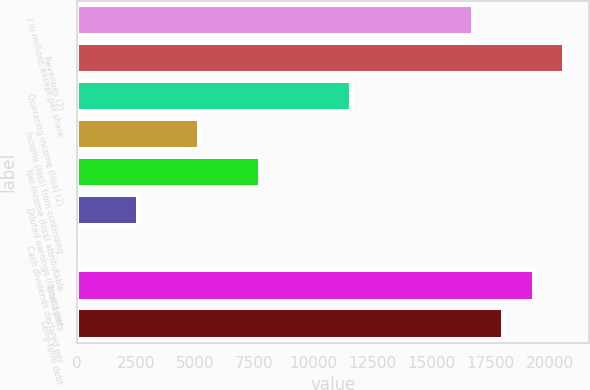Convert chart. <chart><loc_0><loc_0><loc_500><loc_500><bar_chart><fcel>( in millions except per share<fcel>Revenues (2)<fcel>Operating income (loss) (2)<fcel>Income (loss) from continuing<fcel>Net income (loss) attributable<fcel>Diluted earnings (losses) per<fcel>Cash dividends declared per<fcel>Total assets<fcel>Long-term debt<nl><fcel>16742.6<fcel>20606.2<fcel>11591.2<fcel>5151.81<fcel>7727.55<fcel>2576.07<fcel>0.33<fcel>19318.4<fcel>18030.5<nl></chart> 